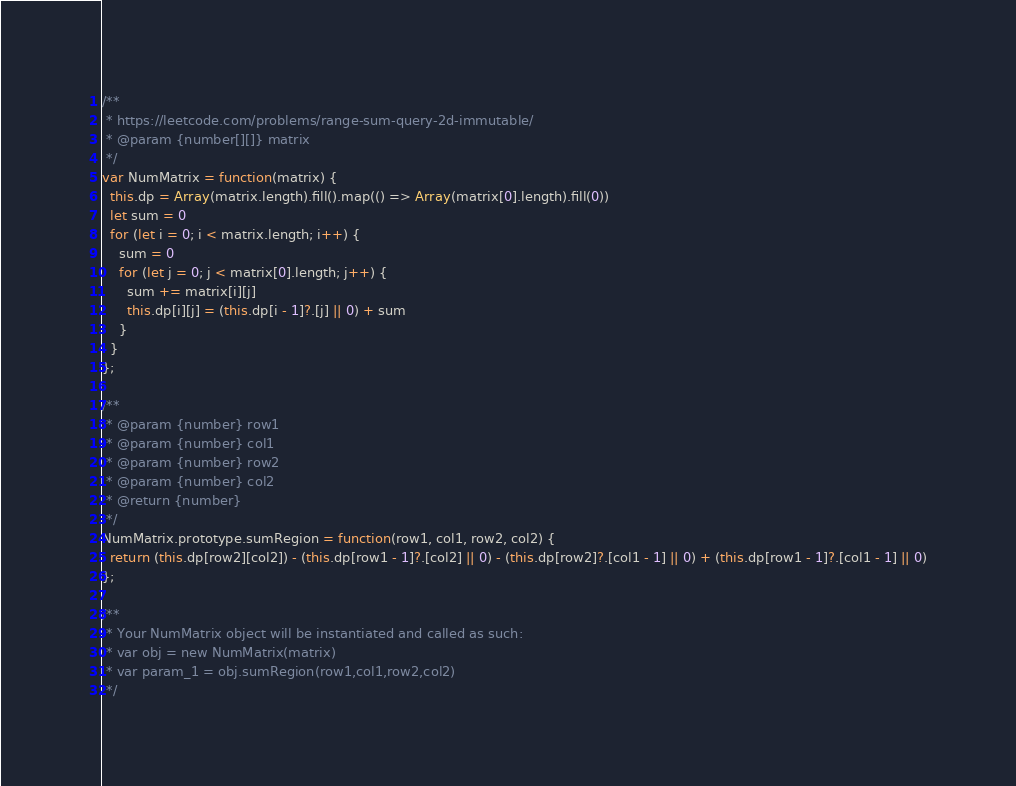<code> <loc_0><loc_0><loc_500><loc_500><_JavaScript_>/**
 * https://leetcode.com/problems/range-sum-query-2d-immutable/
 * @param {number[][]} matrix
 */
var NumMatrix = function(matrix) {
  this.dp = Array(matrix.length).fill().map(() => Array(matrix[0].length).fill(0))
  let sum = 0
  for (let i = 0; i < matrix.length; i++) {
    sum = 0
    for (let j = 0; j < matrix[0].length; j++) {
      sum += matrix[i][j]
      this.dp[i][j] = (this.dp[i - 1]?.[j] || 0) + sum
    }
  }
};

/**
 * @param {number} row1
 * @param {number} col1
 * @param {number} row2
 * @param {number} col2
 * @return {number}
 */
NumMatrix.prototype.sumRegion = function(row1, col1, row2, col2) {
  return (this.dp[row2][col2]) - (this.dp[row1 - 1]?.[col2] || 0) - (this.dp[row2]?.[col1 - 1] || 0) + (this.dp[row1 - 1]?.[col1 - 1] || 0)
};

/**
 * Your NumMatrix object will be instantiated and called as such:
 * var obj = new NumMatrix(matrix)
 * var param_1 = obj.sumRegion(row1,col1,row2,col2)
 */
</code> 